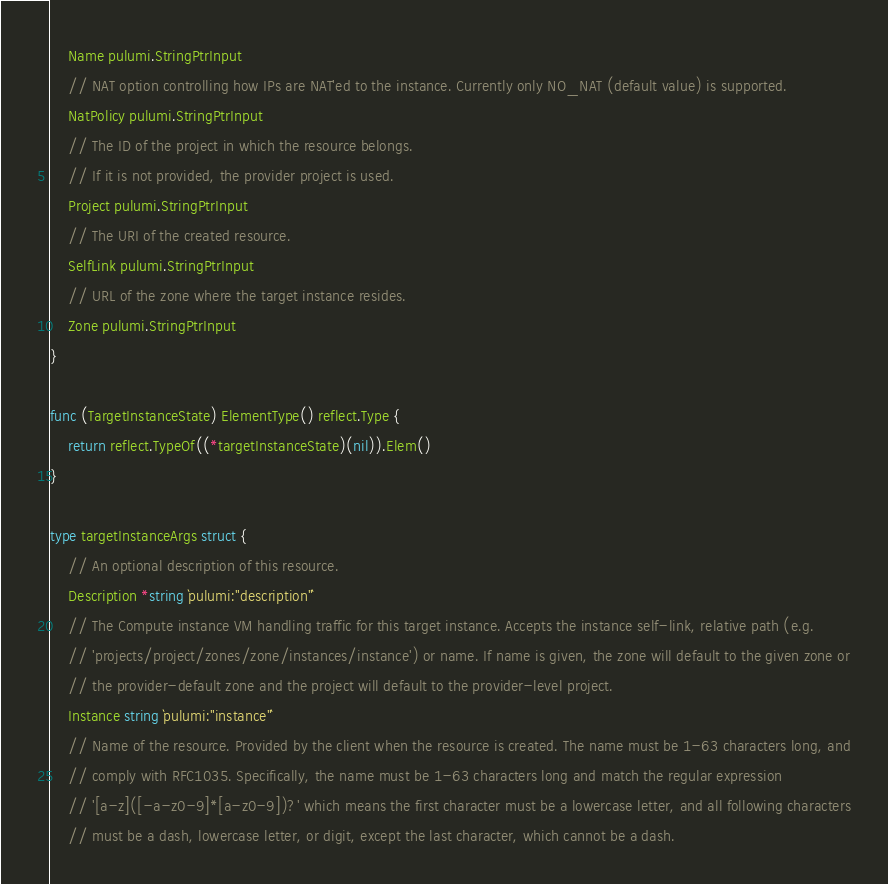Convert code to text. <code><loc_0><loc_0><loc_500><loc_500><_Go_>	Name pulumi.StringPtrInput
	// NAT option controlling how IPs are NAT'ed to the instance. Currently only NO_NAT (default value) is supported.
	NatPolicy pulumi.StringPtrInput
	// The ID of the project in which the resource belongs.
	// If it is not provided, the provider project is used.
	Project pulumi.StringPtrInput
	// The URI of the created resource.
	SelfLink pulumi.StringPtrInput
	// URL of the zone where the target instance resides.
	Zone pulumi.StringPtrInput
}

func (TargetInstanceState) ElementType() reflect.Type {
	return reflect.TypeOf((*targetInstanceState)(nil)).Elem()
}

type targetInstanceArgs struct {
	// An optional description of this resource.
	Description *string `pulumi:"description"`
	// The Compute instance VM handling traffic for this target instance. Accepts the instance self-link, relative path (e.g.
	// 'projects/project/zones/zone/instances/instance') or name. If name is given, the zone will default to the given zone or
	// the provider-default zone and the project will default to the provider-level project.
	Instance string `pulumi:"instance"`
	// Name of the resource. Provided by the client when the resource is created. The name must be 1-63 characters long, and
	// comply with RFC1035. Specifically, the name must be 1-63 characters long and match the regular expression
	// '[a-z]([-a-z0-9]*[a-z0-9])?' which means the first character must be a lowercase letter, and all following characters
	// must be a dash, lowercase letter, or digit, except the last character, which cannot be a dash.</code> 